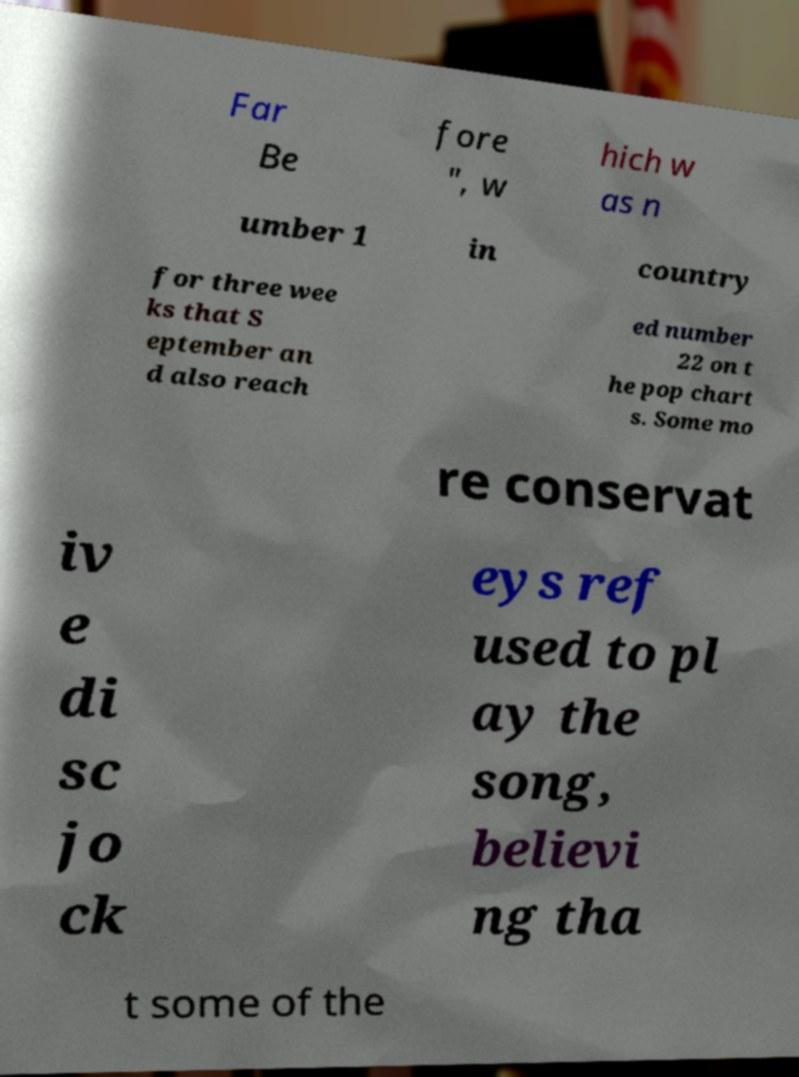Can you accurately transcribe the text from the provided image for me? Far Be fore ", w hich w as n umber 1 in country for three wee ks that S eptember an d also reach ed number 22 on t he pop chart s. Some mo re conservat iv e di sc jo ck eys ref used to pl ay the song, believi ng tha t some of the 